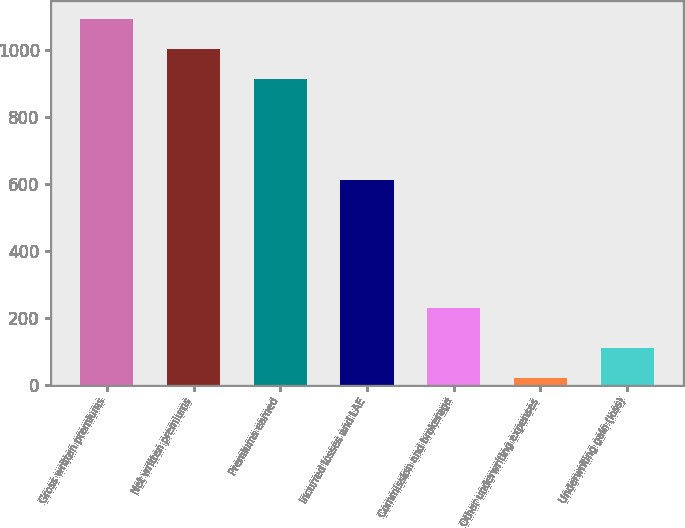<chart> <loc_0><loc_0><loc_500><loc_500><bar_chart><fcel>Gross written premiums<fcel>Net written premiums<fcel>Premiums earned<fcel>Incurred losses and LAE<fcel>Commission and brokerage<fcel>Other underwriting expenses<fcel>Underwriting gain (loss)<nl><fcel>1093.22<fcel>1003.06<fcel>912.9<fcel>611.2<fcel>230.4<fcel>20.9<fcel>111.06<nl></chart> 